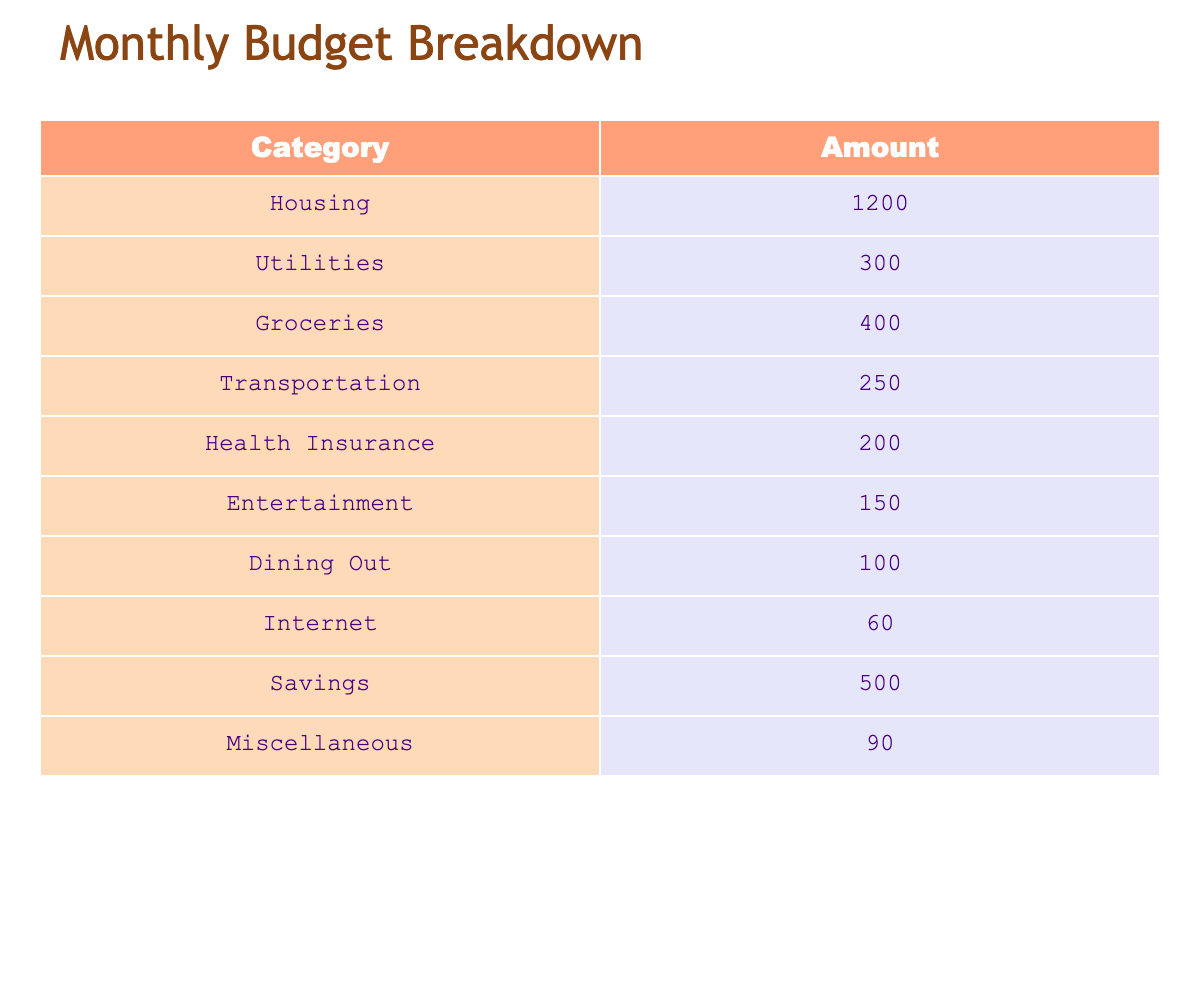What is the total amount allocated for Housing and Utilities? The amount for Housing is 1200 and for Utilities is 300. Adding these two amounts gives 1200 + 300 = 1500.
Answer: 1500 What category has the least amount in the budget? By comparing all the amounts listed, Dining Out has the lowest value of 100.
Answer: Dining Out What percentage of the total budget is spent on Savings? First, calculate the total budget: 1200 + 300 + 400 + 250 + 200 + 150 + 100 + 60 + 500 + 90 = 3050. Savings is 500, so the percentage is (500 / 3050) * 100 = 16.39%.
Answer: 16.39% Is the amount for Transportation greater than the amount for Entertainment? Transportation has an amount of 250 while Entertainment has 150. Since 250 is greater than 150, the statement is true.
Answer: Yes What is the average amount spent on the categories listed? To find the average, first compute the total budget (3050) and then divide it by the number of categories (10). Thus, the average is 3050 / 10 = 305.
Answer: 305 What is the combined amount for Health Insurance and Miscellaneous? Adding the amounts for Health Insurance (200) and Miscellaneous (90) gives 200 + 90 = 290.
Answer: 290 Is the total for Groceries and Dining Out less than the total for Utilities and Transportation? Groceries is 400 and Dining Out is 100, so combined they equal 500. Utilities (300) and Transportation (250) combined is 550. Since 500 is less than 550, the statement is true.
Answer: Yes What are the amounts for the top three categories with the highest expenses? The highest amounts are Housing (1200), Utilities (300), and Groceries (400). Therefore, the top three amounts are 1200, 400, and 300.
Answer: 1200, 400, 300 By how much does the amount for Health Insurance differ from that of Entertainment? Health Insurance is 200 and Entertainment is 150. The difference is 200 - 150 = 50.
Answer: 50 